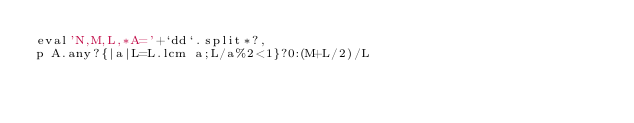<code> <loc_0><loc_0><loc_500><loc_500><_Ruby_>eval'N,M,L,*A='+`dd`.split*?,
p A.any?{|a|L=L.lcm a;L/a%2<1}?0:(M+L/2)/L</code> 